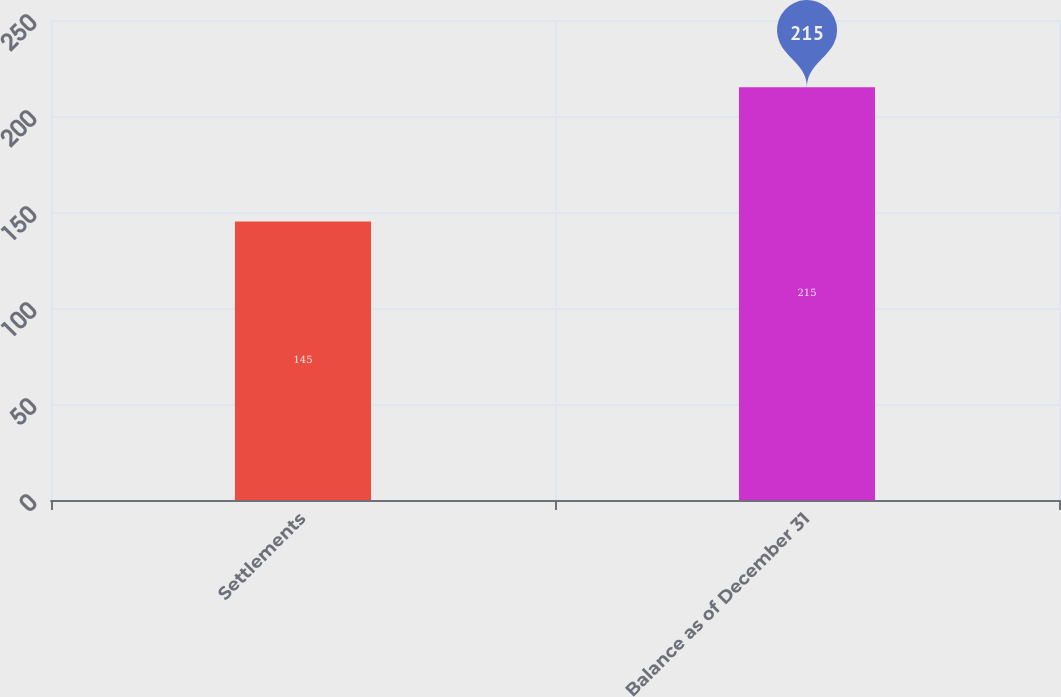Convert chart. <chart><loc_0><loc_0><loc_500><loc_500><bar_chart><fcel>Settlements<fcel>Balance as of December 31<nl><fcel>145<fcel>215<nl></chart> 